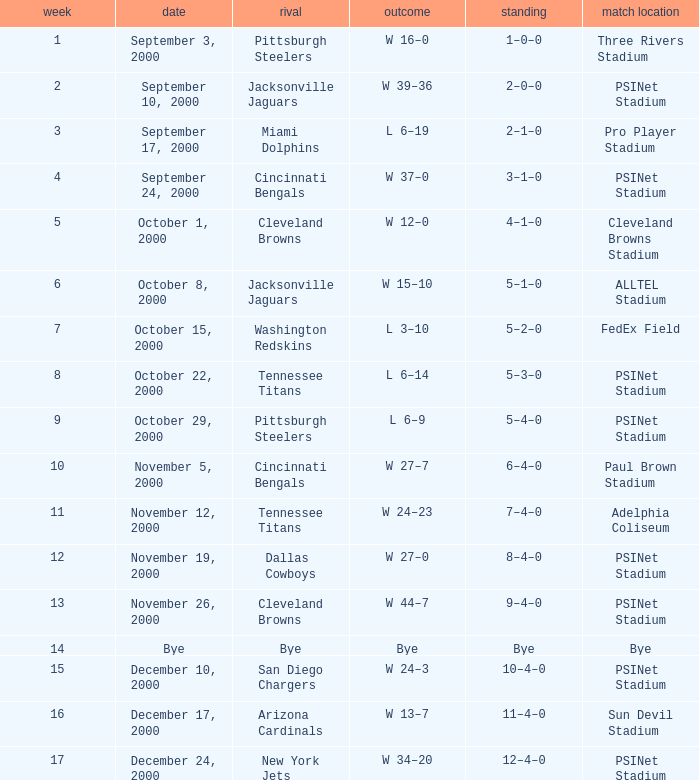What game site has a result of bye? Bye. 